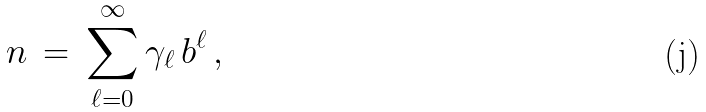Convert formula to latex. <formula><loc_0><loc_0><loc_500><loc_500>n \, = \, \sum _ { \ell = 0 } ^ { \infty } \gamma _ { \ell } \, b ^ { \ell } \, ,</formula> 